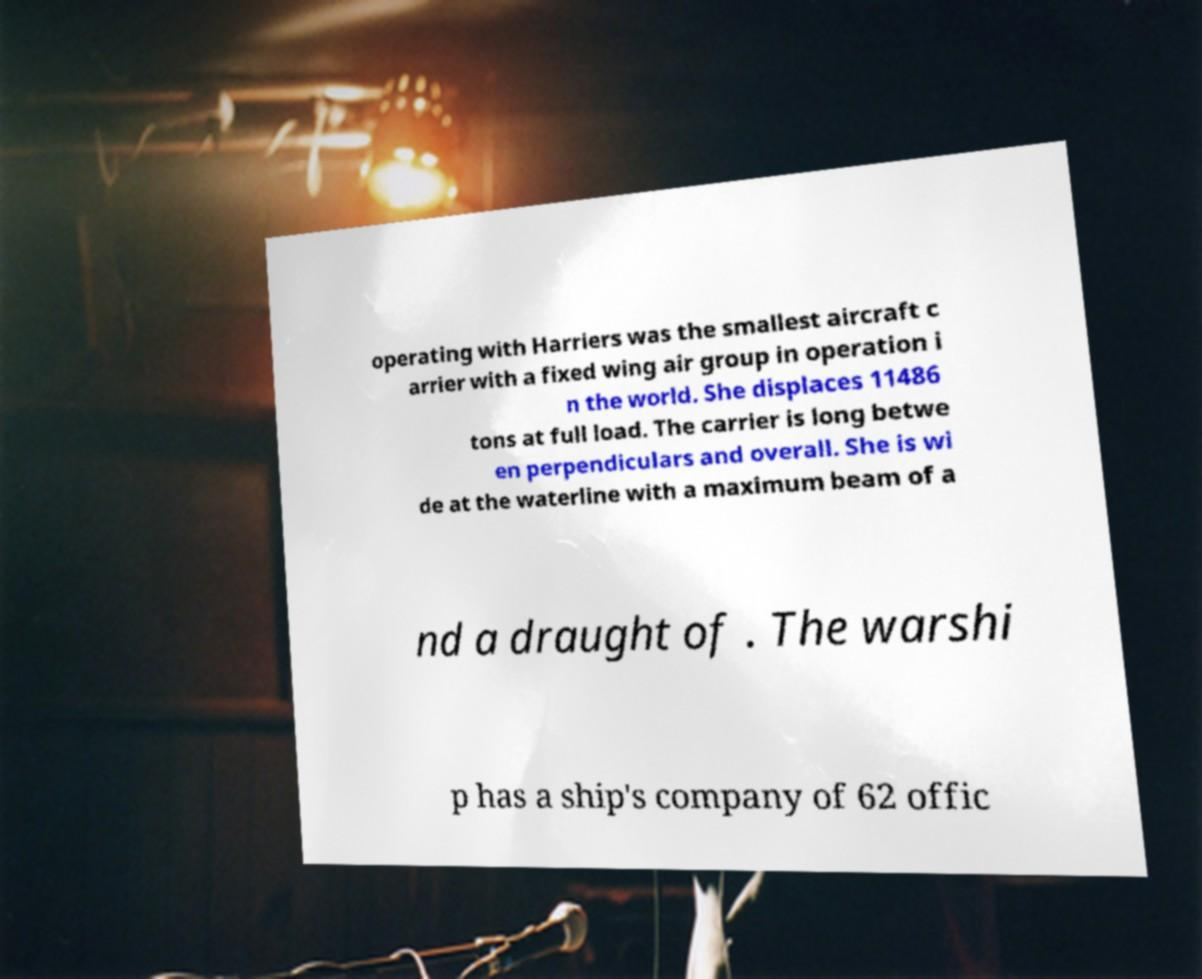Please read and relay the text visible in this image. What does it say? operating with Harriers was the smallest aircraft c arrier with a fixed wing air group in operation i n the world. She displaces 11486 tons at full load. The carrier is long betwe en perpendiculars and overall. She is wi de at the waterline with a maximum beam of a nd a draught of . The warshi p has a ship's company of 62 offic 